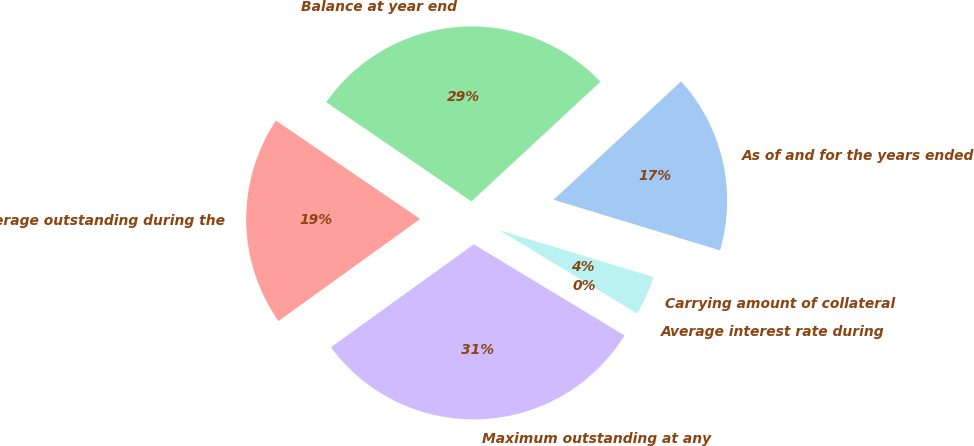Convert chart to OTSL. <chart><loc_0><loc_0><loc_500><loc_500><pie_chart><fcel>As of and for the years ended<fcel>Balance at year end<fcel>Average outstanding during the<fcel>Maximum outstanding at any<fcel>Average interest rate during<fcel>Carrying amount of collateral<nl><fcel>16.61%<fcel>28.56%<fcel>19.47%<fcel>31.41%<fcel>0.0%<fcel>3.95%<nl></chart> 